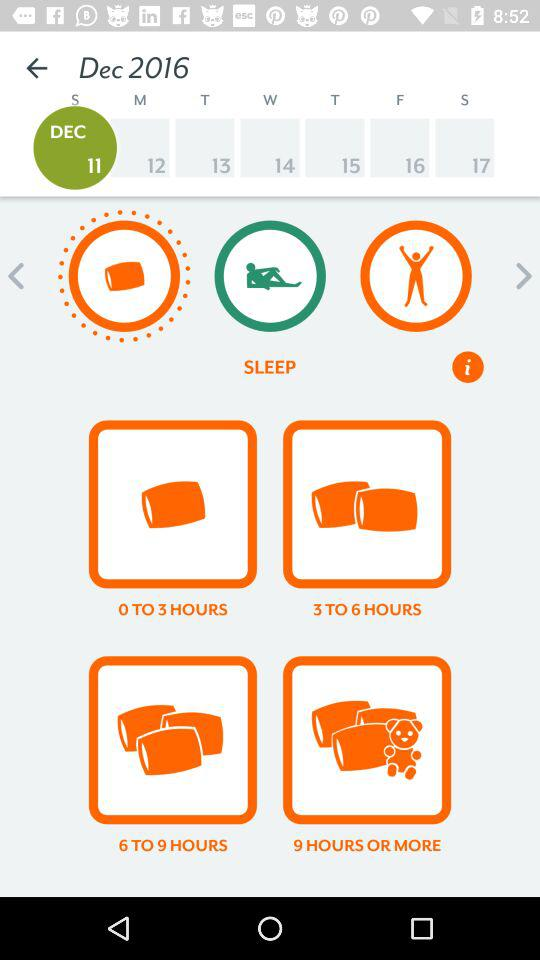What is the day of the scheduled date? The day is Sunday. 